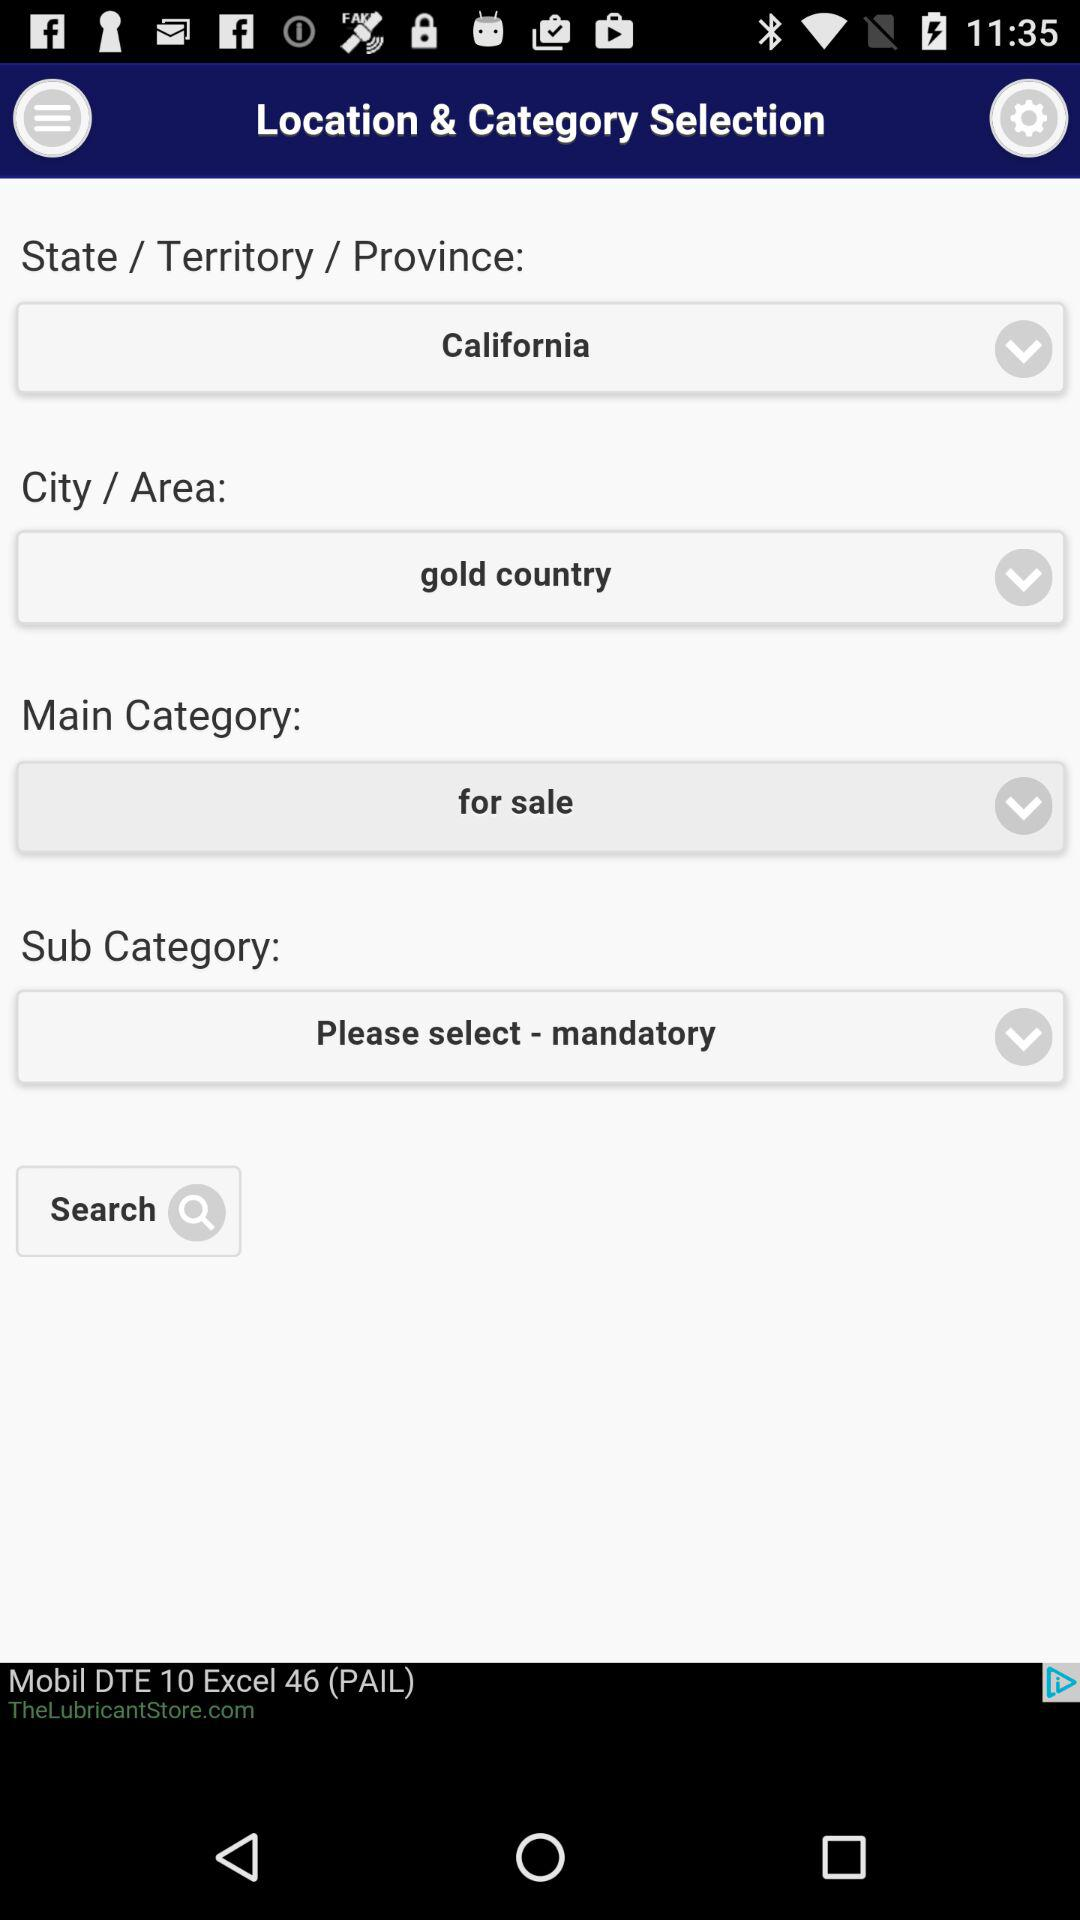What is the selected city? The selected city is "gold country". 